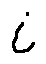<formula> <loc_0><loc_0><loc_500><loc_500>i</formula> 